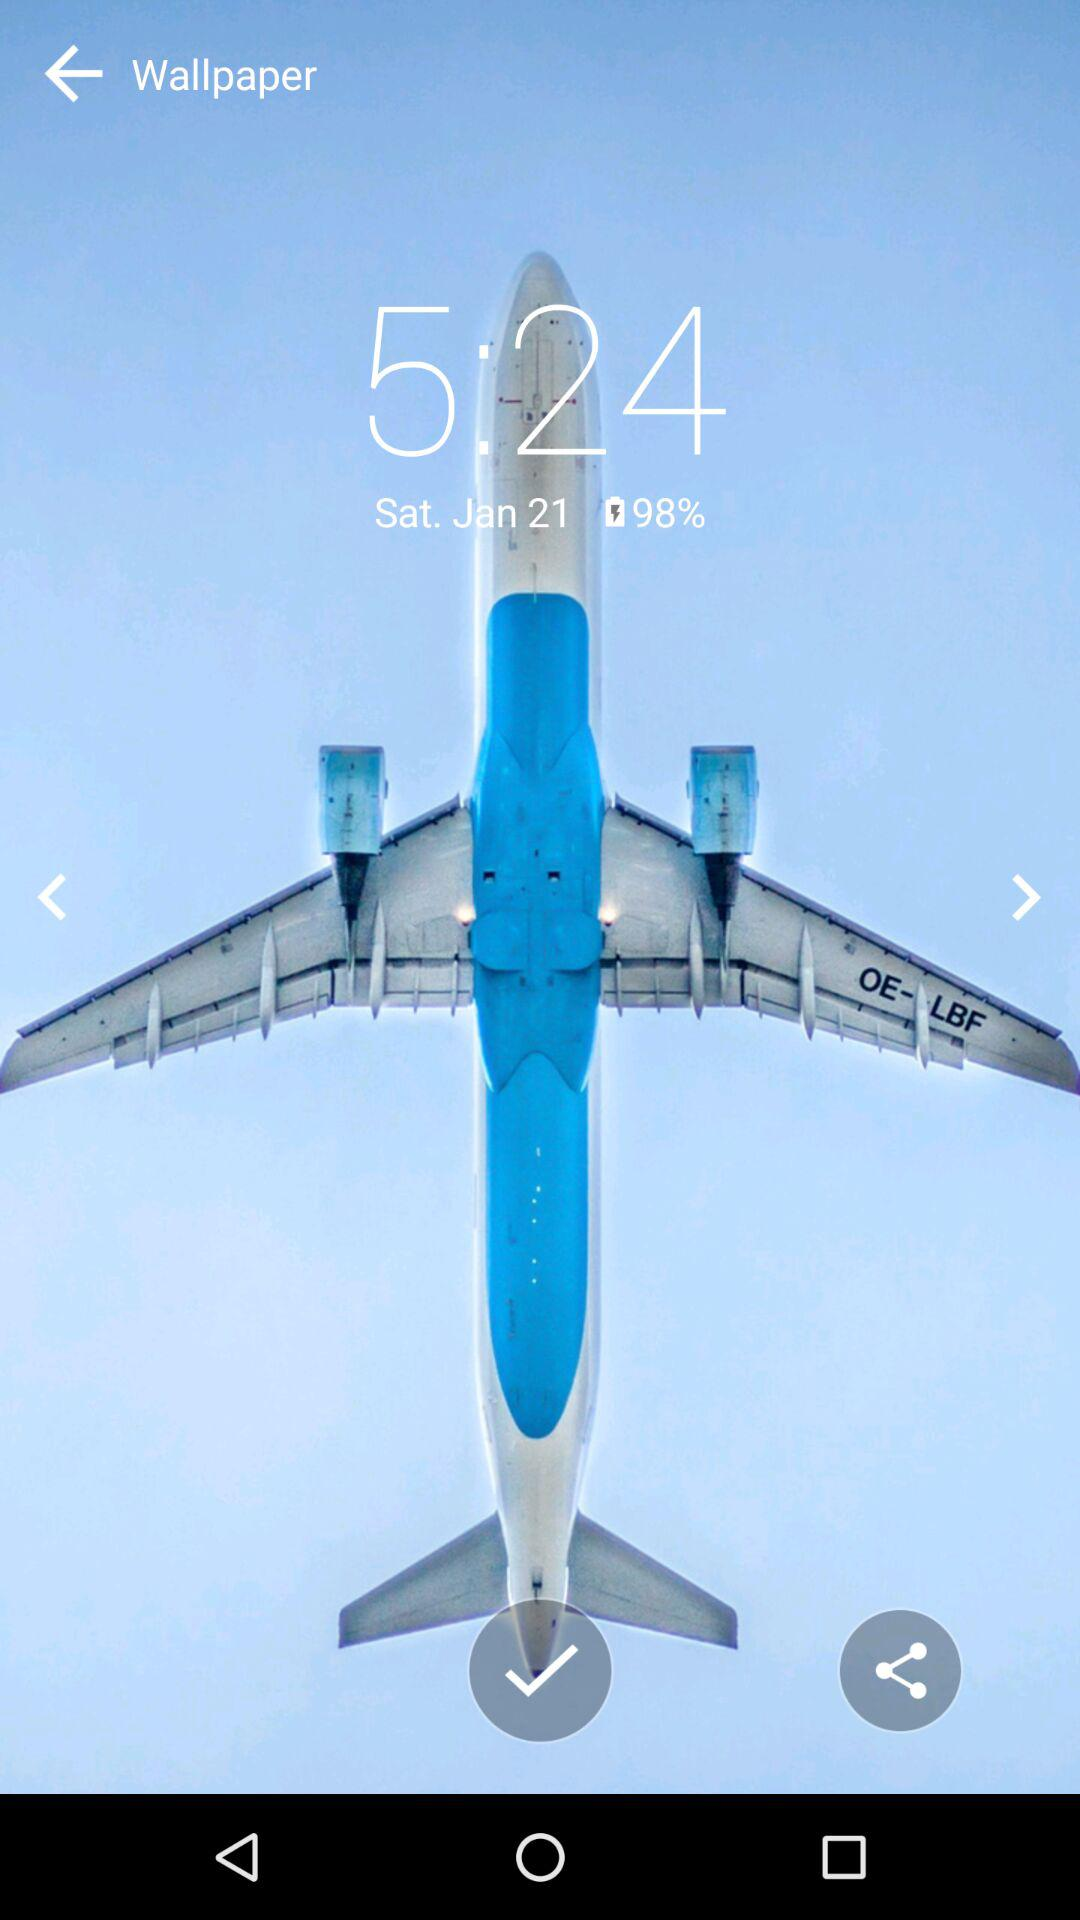What is the battery percentage? The battery percentage is 98. 